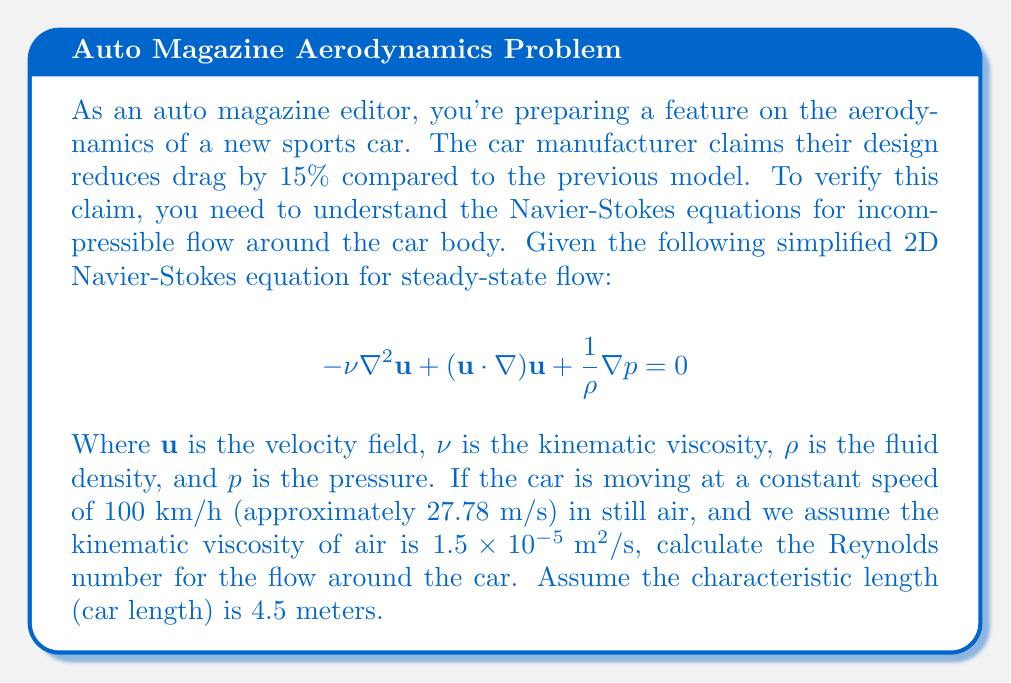Teach me how to tackle this problem. To solve this problem, we need to understand the concept of the Reynolds number and how it relates to the Navier-Stokes equations.

The Reynolds number (Re) is a dimensionless quantity that helps predict flow patterns in different fluid flow situations. It's defined as:

$$Re = \frac{UL}{\nu}$$

Where:
$U$ is the characteristic velocity (in this case, the car's speed)
$L$ is the characteristic length (in this case, the car's length)
$\nu$ is the kinematic viscosity of the fluid (air in this case)

Let's plug in our values:

$U = 27.78 \text{ m/s}$ (converted from 100 km/h)
$L = 4.5 \text{ m}$
$\nu = 1.5 \times 10^{-5} \text{ m}^2/\text{s}$

Now, let's calculate:

$$\begin{align}
Re &= \frac{UL}{\nu} \\[10pt]
&= \frac{(27.78 \text{ m/s})(4.5 \text{ m})}{1.5 \times 10^{-5} \text{ m}^2/\text{s}} \\[10pt]
&= \frac{125.01}{1.5 \times 10^{-5}} \\[10pt]
&= 8,334,000
\end{align}$$

This high Reynolds number (Re > 4000) indicates that the flow around the car is turbulent, which is typical for automotive aerodynamics. Turbulent flow is characterized by irregular fluctuations and mixing within the fluid, which significantly affects drag and other aerodynamic properties.

Understanding this Reynolds number is crucial for interpreting the Navier-Stokes equations and the car's aerodynamic performance. The high Re value suggests that the inertial forces dominate over viscous forces, which is why the $(u \cdot \nabla)u$ term (representing inertial forces) in the Navier-Stokes equation is significant for this flow regime.
Answer: The Reynolds number for the flow around the car is approximately 8,334,000. 